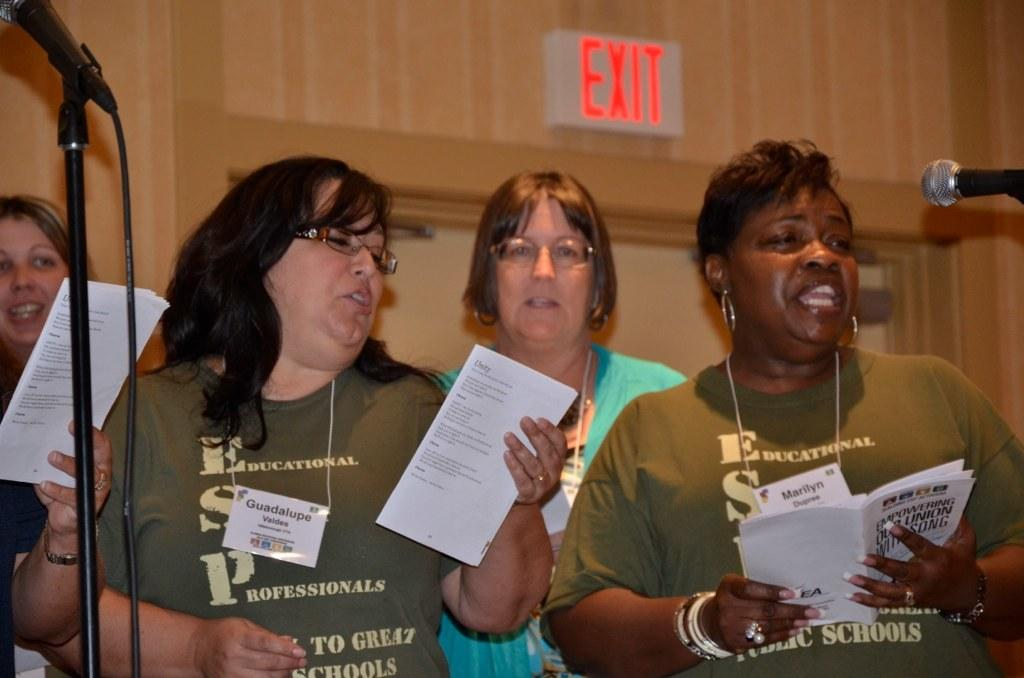How many people are in the image? There are people in the image, but the exact number is not specified. What are the people doing in the image? The people are standing and singing a song. What objects are the people holding in the image? The people are holding books in their hands. What can be seen on the wall in the image? There is an exit board on the wall in the image. What type of flower is growing on the floor in the image? There is no flower growing on the floor in the image. 